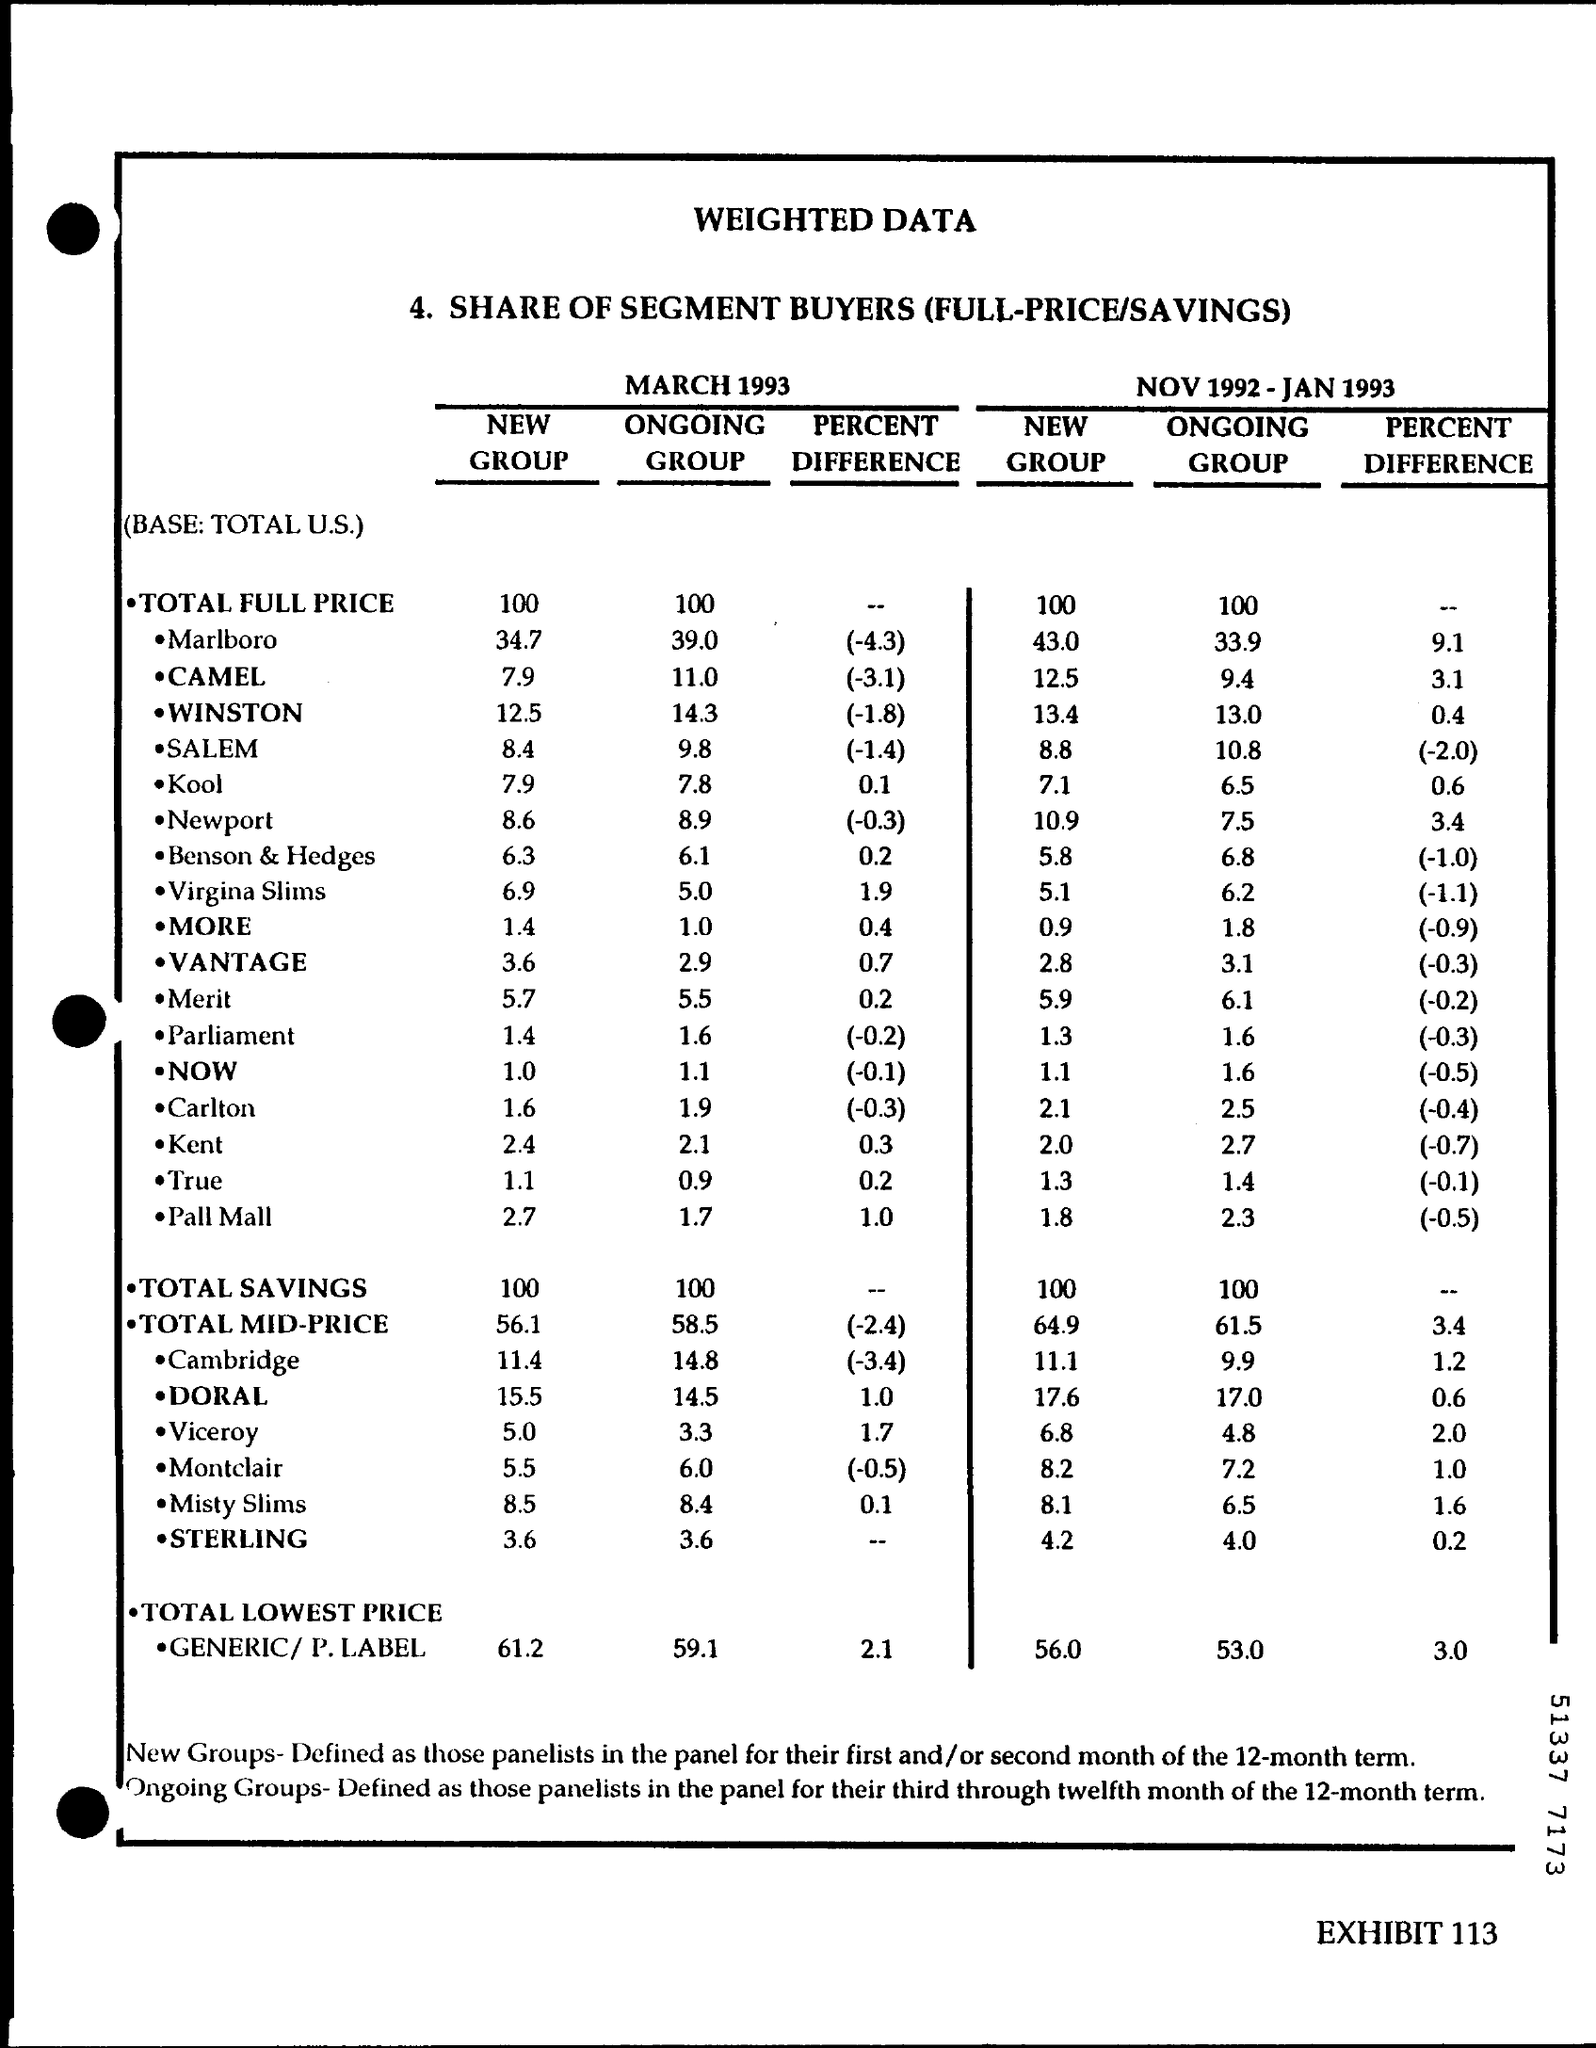What is written in the Letter Head ?
Make the answer very short. Weighted data. 